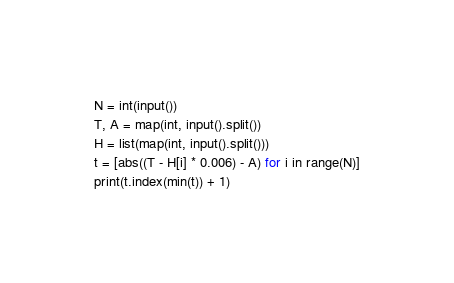<code> <loc_0><loc_0><loc_500><loc_500><_Python_>N = int(input())
T, A = map(int, input().split())
H = list(map(int, input().split()))
t = [abs((T - H[i] * 0.006) - A) for i in range(N)]
print(t.index(min(t)) + 1)
</code> 